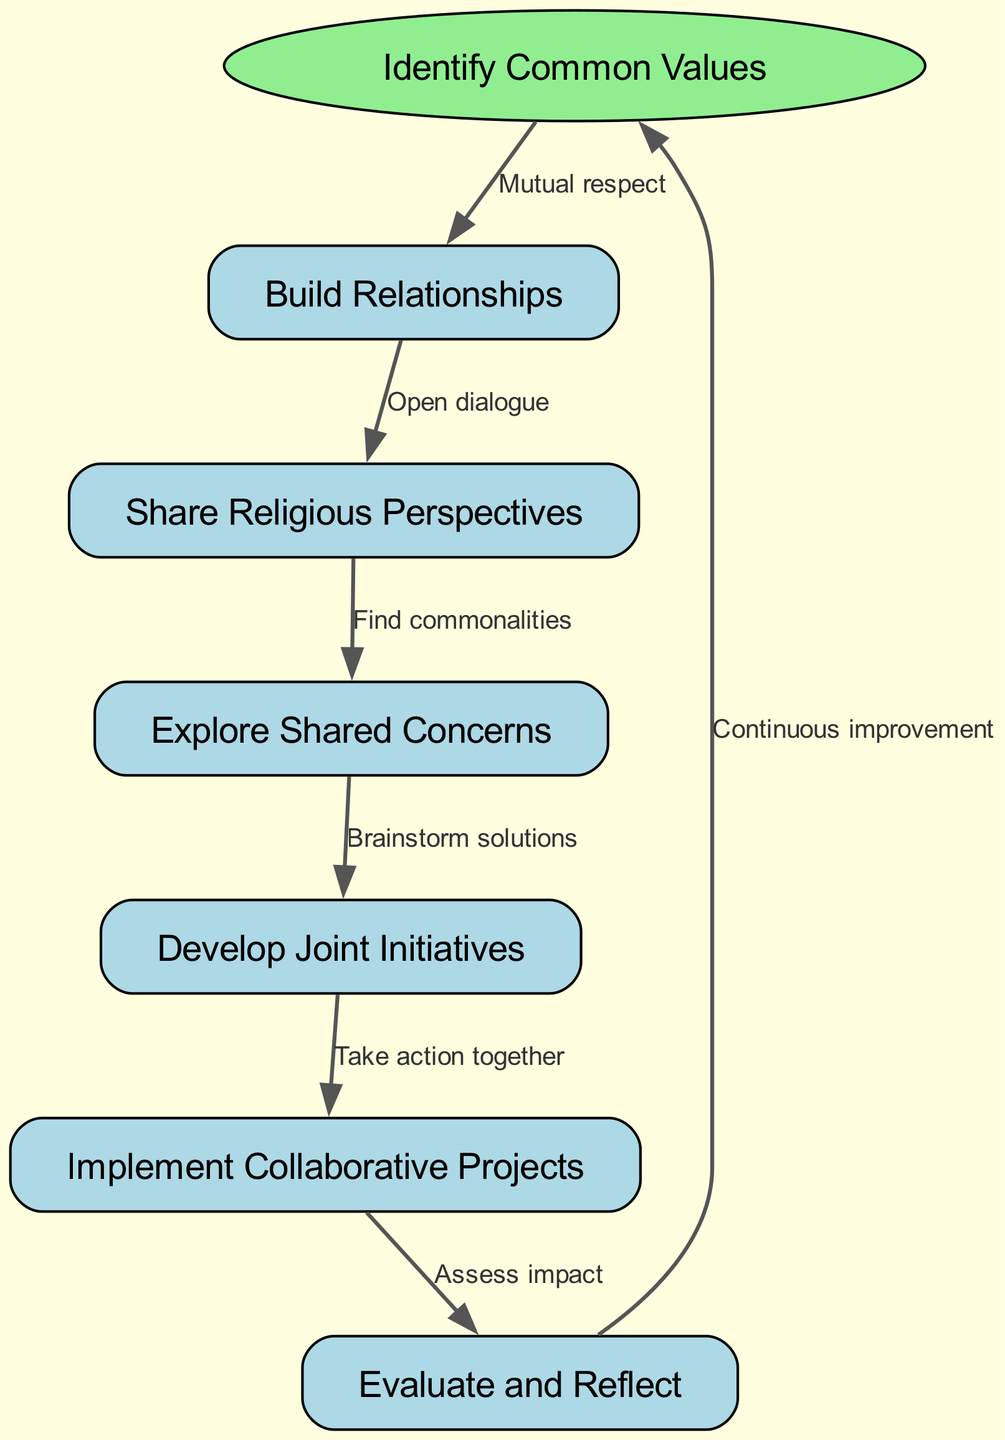What is the starting point of the flowchart? The flowchart begins with the node labeled "Identify Common Values." This can be determined by looking for the node that is distinctly labeled as the starting point or is depicted in a different shape, which in this case is an oval shape.
Answer: Identify Common Values How many nodes are present in the diagram? The diagram contains a total of 7 nodes. This includes the starting node plus the additional nodes listed in the data. To find the total, we can count the start node and the nodes from the list provided in the data.
Answer: 7 What is the relationship that leads from "Explore Shared Concerns" to "Develop Joint Initiatives"? The relationship from "Explore Shared Concerns" to "Develop Joint Initiatives" is labeled "Brainstorm solutions." This label describes the action or connection between these two nodes, revealing how the dialogue transitions from one element to the next.
Answer: Brainstorm solutions Which node follows "Implement Collaborative Projects"? The node that follows "Implement Collaborative Projects" is labeled "Evaluate and Reflect." We can identify this by locating the outgoing edge from "Implement Collaborative Projects." This edge points to the next node in the process.
Answer: Evaluate and Reflect What is the final step in the flow of the process? The final step in the flow of the process is "Evaluate and Reflect." This step is reached after implementing collaborative projects due to the structured progression outlined in the diagram.
Answer: Evaluate and Reflect What is the connecting label from "Share Religious Perspectives" to "Explore Shared Concerns"? The label connecting "Share Religious Perspectives" to "Explore Shared Concerns" is "Find commonalities." It indicates the nature of the dialogue occurring during this step in the interfaith dialogue process.
Answer: Find commonalities What action does "Build Relationships" encourage before moving to "Share Religious Perspectives"? "Build Relationships" encourages "Open dialogue" before moving on to "Share Religious Perspectives." This describes the process in which relationships are established that promote further discussion.
Answer: Open dialogue How does "Evaluate and Reflect" relate back to "Identify Common Values"? "Evaluate and Reflect" relates back to "Identify Common Values" through the label "Continuous improvement." This indicates a cyclical process where reflection leads back to reassessing common values.
Answer: Continuous improvement 